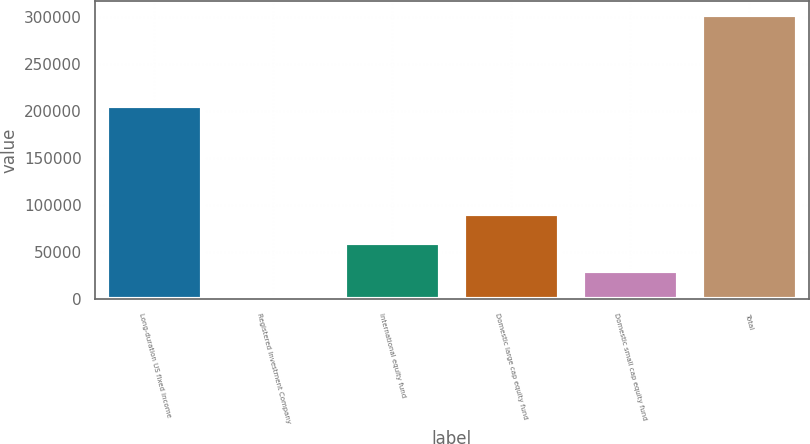<chart> <loc_0><loc_0><loc_500><loc_500><bar_chart><fcel>Long-duration US fixed income<fcel>Registered Investment Company<fcel>International equity fund<fcel>Domestic large cap equity fund<fcel>Domestic small cap equity fund<fcel>Total<nl><fcel>205695<fcel>4.33<fcel>60321.1<fcel>90479.4<fcel>30162.7<fcel>301588<nl></chart> 